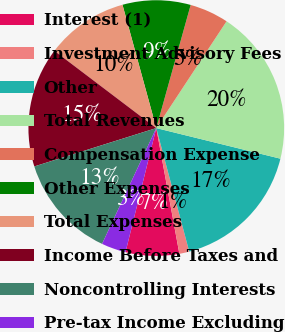Convert chart to OTSL. <chart><loc_0><loc_0><loc_500><loc_500><pie_chart><fcel>Interest (1)<fcel>Investment Advisory Fees<fcel>Other<fcel>Total Revenues<fcel>Compensation Expense<fcel>Other Expenses<fcel>Total Expenses<fcel>Income Before Taxes and<fcel>Noncontrolling Interests<fcel>Pre-tax Income Excluding<nl><fcel>6.76%<fcel>1.26%<fcel>17.0%<fcel>19.58%<fcel>4.93%<fcel>8.59%<fcel>10.42%<fcel>15.17%<fcel>13.18%<fcel>3.1%<nl></chart> 